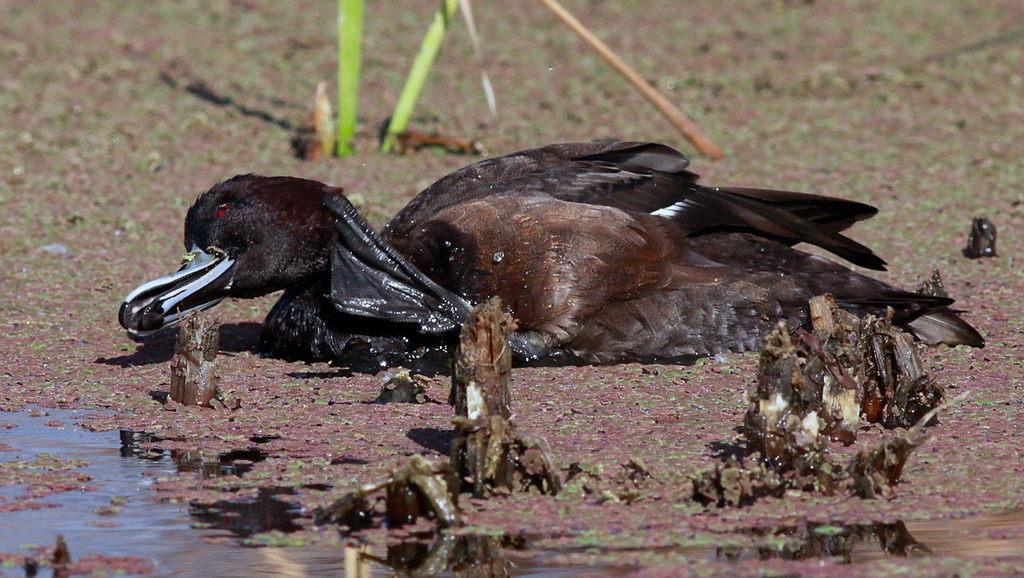Can you describe this image briefly? In the picture we can see a bird laid on the surface and near to it we can see some water and the bird in black in color with some part of brown. 